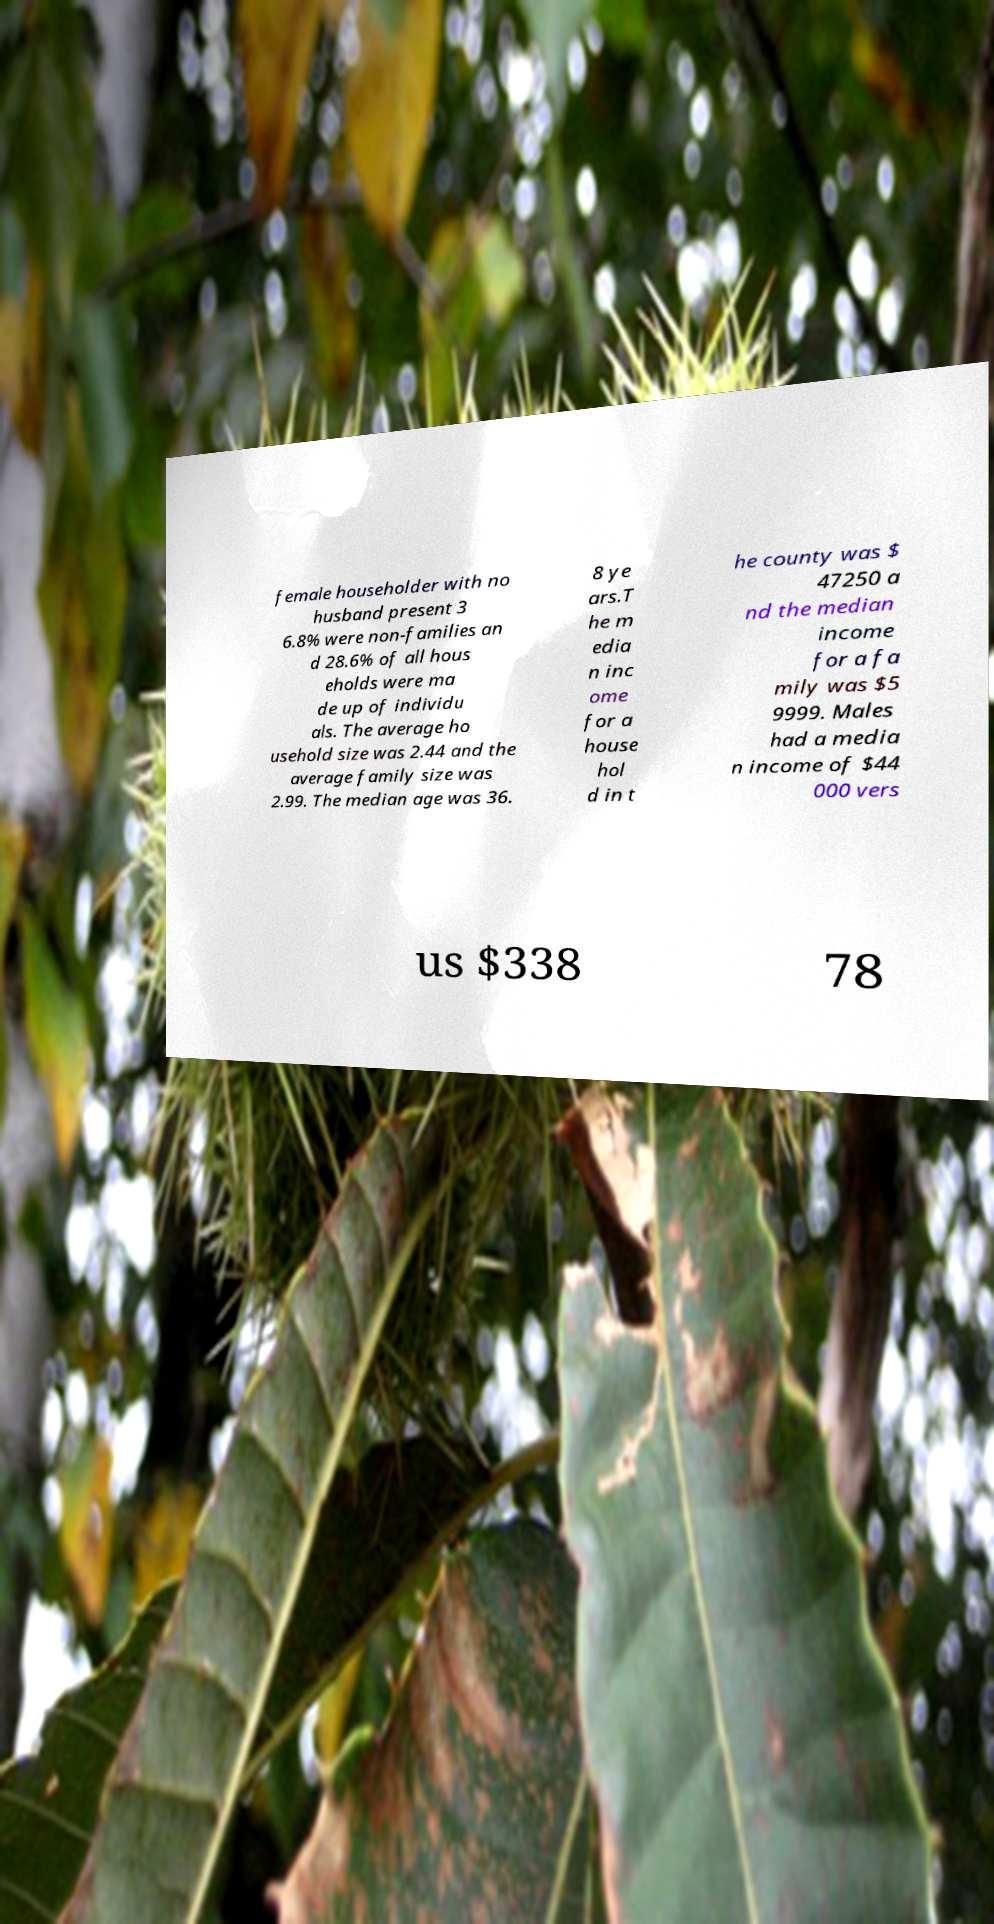Please read and relay the text visible in this image. What does it say? female householder with no husband present 3 6.8% were non-families an d 28.6% of all hous eholds were ma de up of individu als. The average ho usehold size was 2.44 and the average family size was 2.99. The median age was 36. 8 ye ars.T he m edia n inc ome for a house hol d in t he county was $ 47250 a nd the median income for a fa mily was $5 9999. Males had a media n income of $44 000 vers us $338 78 